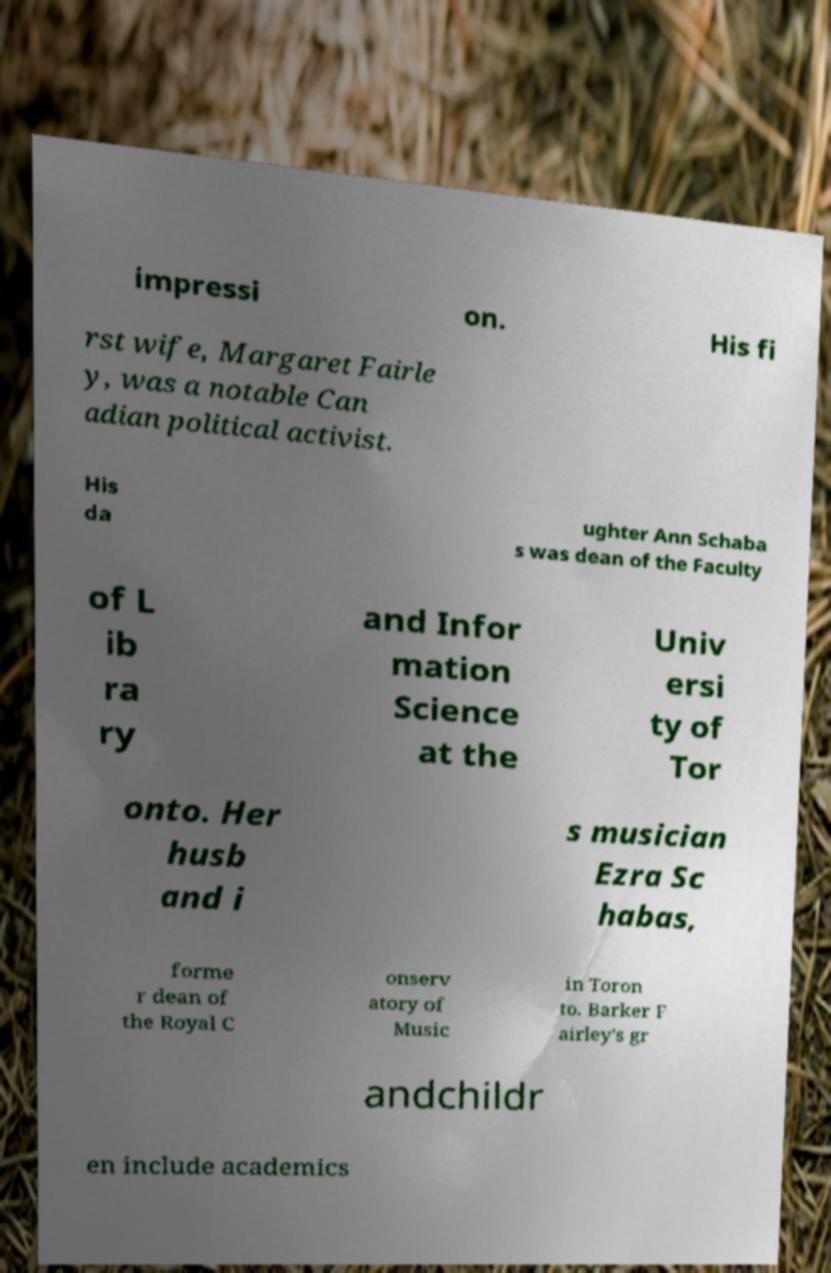There's text embedded in this image that I need extracted. Can you transcribe it verbatim? impressi on. His fi rst wife, Margaret Fairle y, was a notable Can adian political activist. His da ughter Ann Schaba s was dean of the Faculty of L ib ra ry and Infor mation Science at the Univ ersi ty of Tor onto. Her husb and i s musician Ezra Sc habas, forme r dean of the Royal C onserv atory of Music in Toron to. Barker F airley's gr andchildr en include academics 